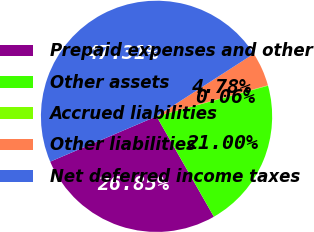Convert chart to OTSL. <chart><loc_0><loc_0><loc_500><loc_500><pie_chart><fcel>Prepaid expenses and other<fcel>Other assets<fcel>Accrued liabilities<fcel>Other liabilities<fcel>Net deferred income taxes<nl><fcel>26.85%<fcel>21.0%<fcel>0.06%<fcel>4.78%<fcel>47.31%<nl></chart> 